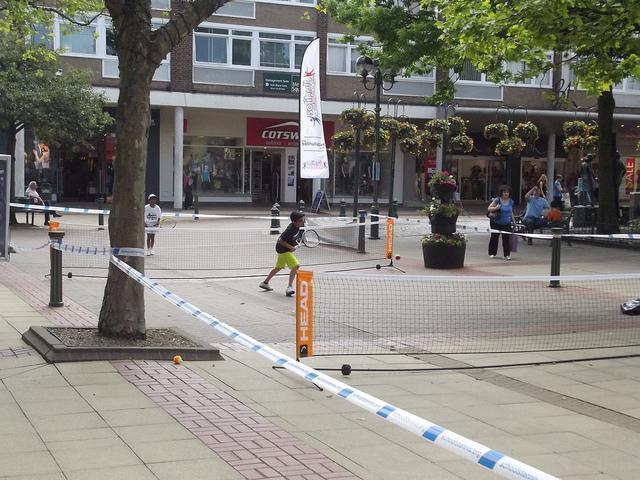Who is playing tennis with the boy wearing yellow pants?
Choose the right answer and clarify with the format: 'Answer: answer
Rationale: rationale.'
Options: Woman, young man, boy, old man. Answer: woman.
Rationale: A woman is standing on the other side of a tennis court from a boy in yellow. 